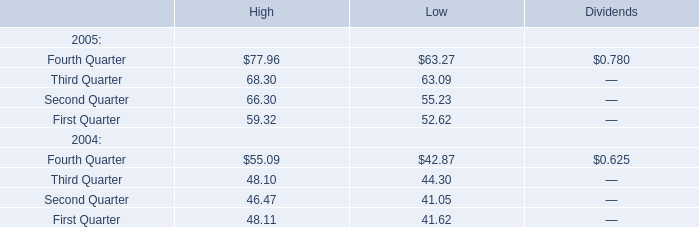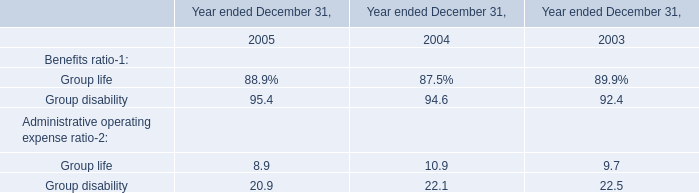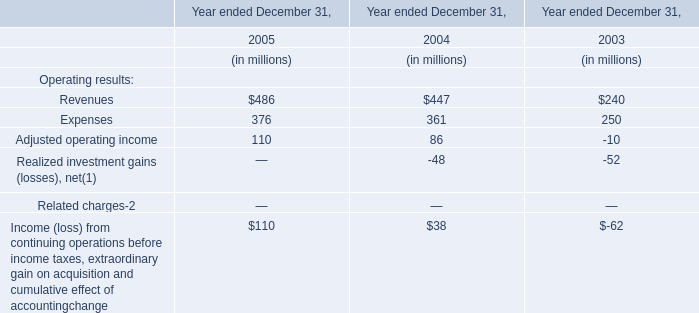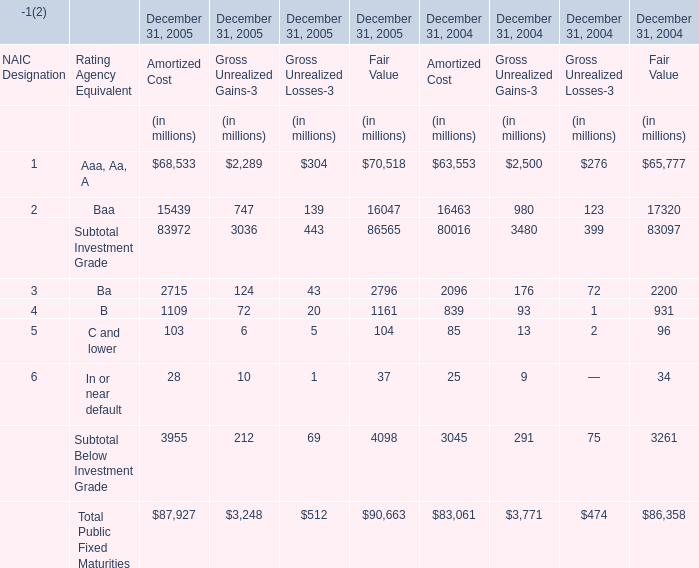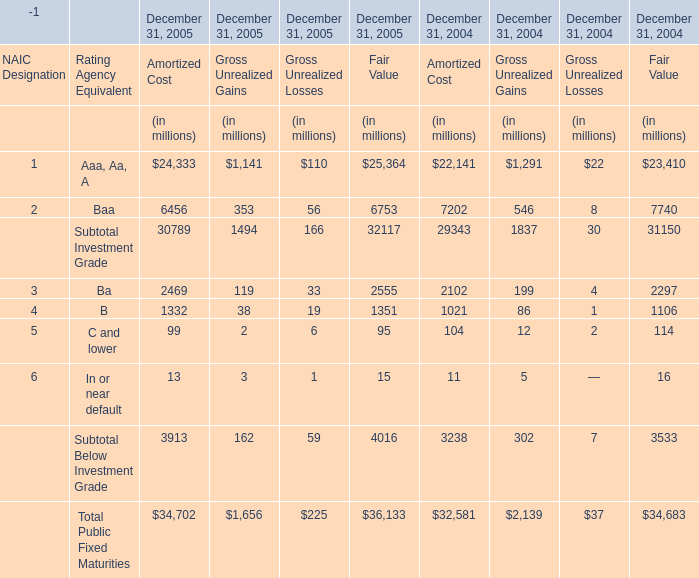What's the average of Amortized Cost in 2005 for December 31, 2005? (in million) 
Computations: (((((((68533 + 15439) + 2715) + 1109) + 103) + 28) + 87927) / 7)
Answer: 25122.0. 